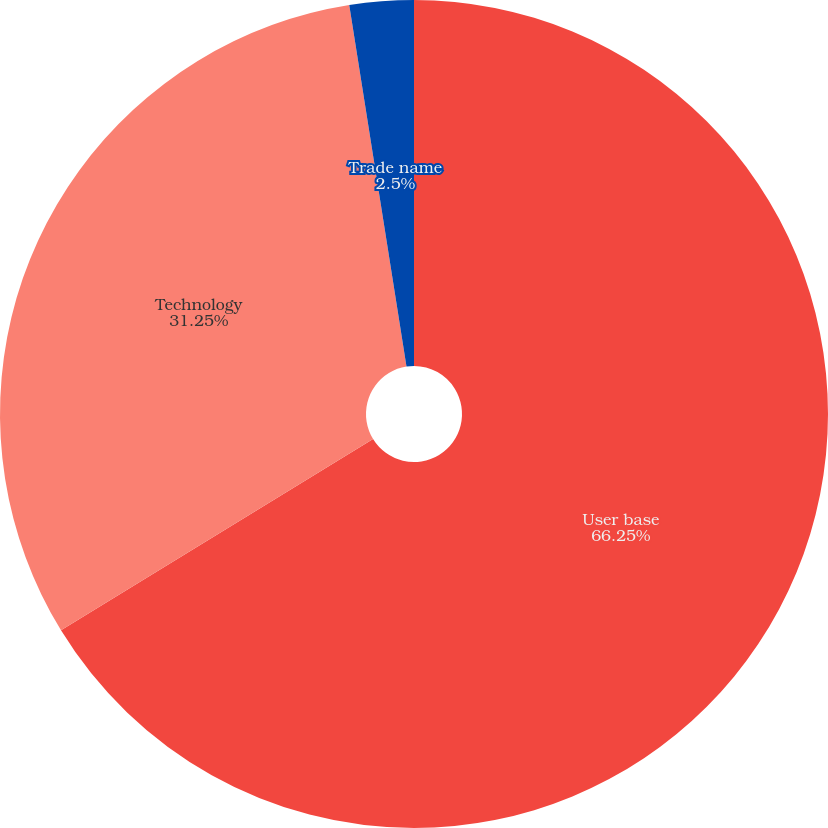Convert chart. <chart><loc_0><loc_0><loc_500><loc_500><pie_chart><fcel>User base<fcel>Technology<fcel>Trade name<nl><fcel>66.25%<fcel>31.25%<fcel>2.5%<nl></chart> 